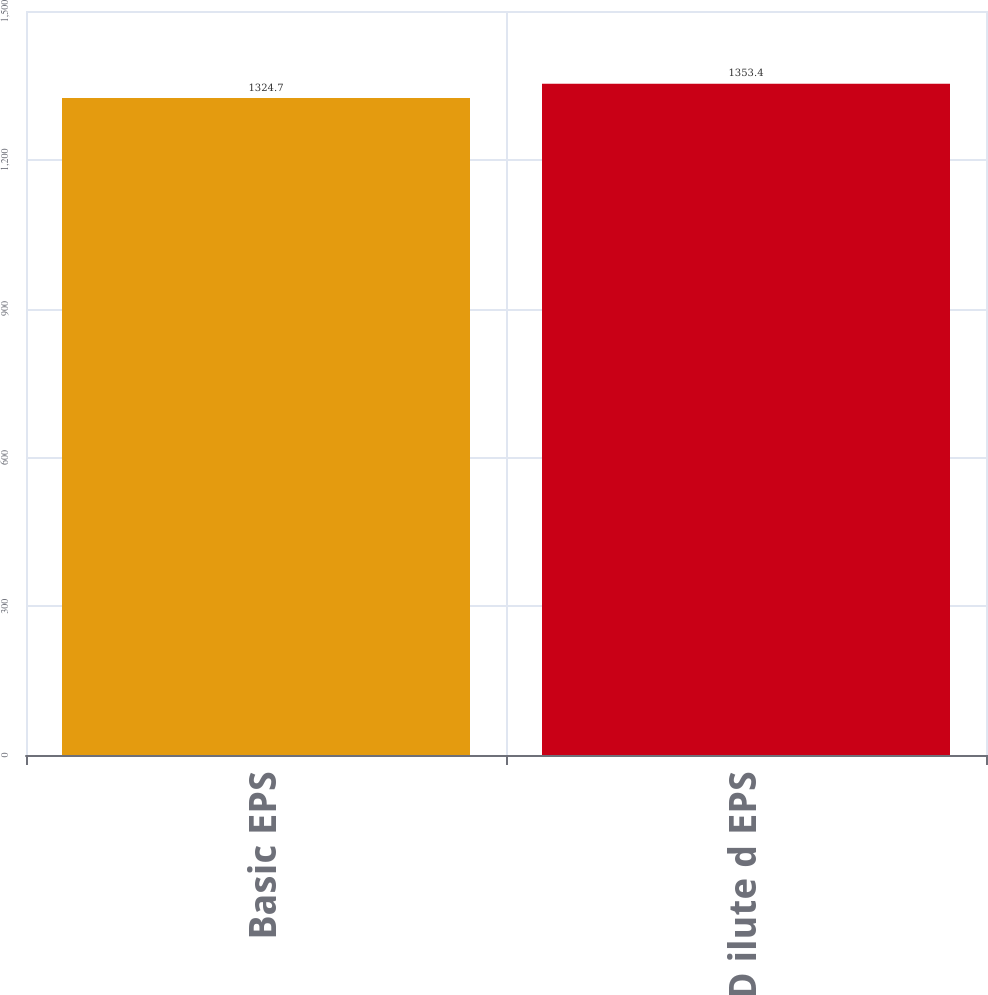Convert chart to OTSL. <chart><loc_0><loc_0><loc_500><loc_500><bar_chart><fcel>Basic EPS<fcel>D ilute d EPS<nl><fcel>1324.7<fcel>1353.4<nl></chart> 